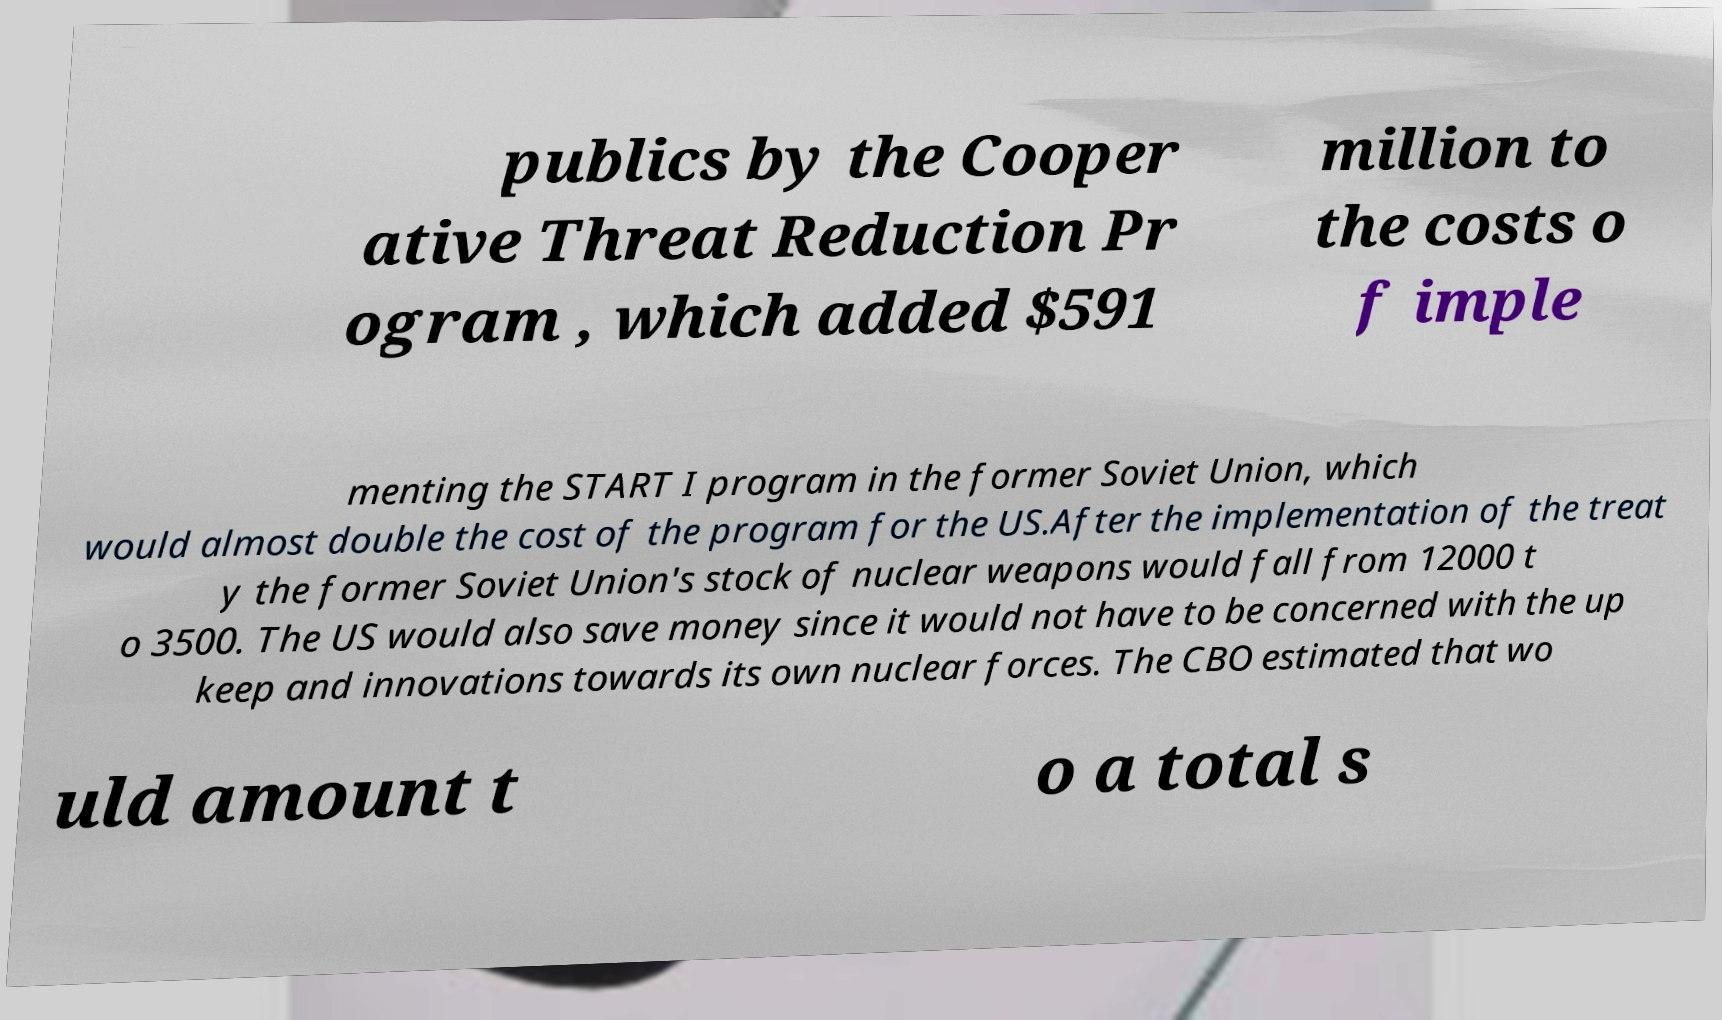Could you assist in decoding the text presented in this image and type it out clearly? publics by the Cooper ative Threat Reduction Pr ogram , which added $591 million to the costs o f imple menting the START I program in the former Soviet Union, which would almost double the cost of the program for the US.After the implementation of the treat y the former Soviet Union's stock of nuclear weapons would fall from 12000 t o 3500. The US would also save money since it would not have to be concerned with the up keep and innovations towards its own nuclear forces. The CBO estimated that wo uld amount t o a total s 